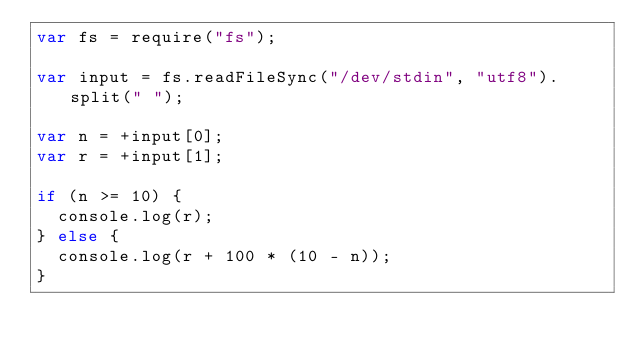Convert code to text. <code><loc_0><loc_0><loc_500><loc_500><_JavaScript_>var fs = require("fs");

var input = fs.readFileSync("/dev/stdin", "utf8").split(" ");

var n = +input[0];
var r = +input[1];

if (n >= 10) {
  console.log(r);
} else {
  console.log(r + 100 * (10 - n));
}
</code> 